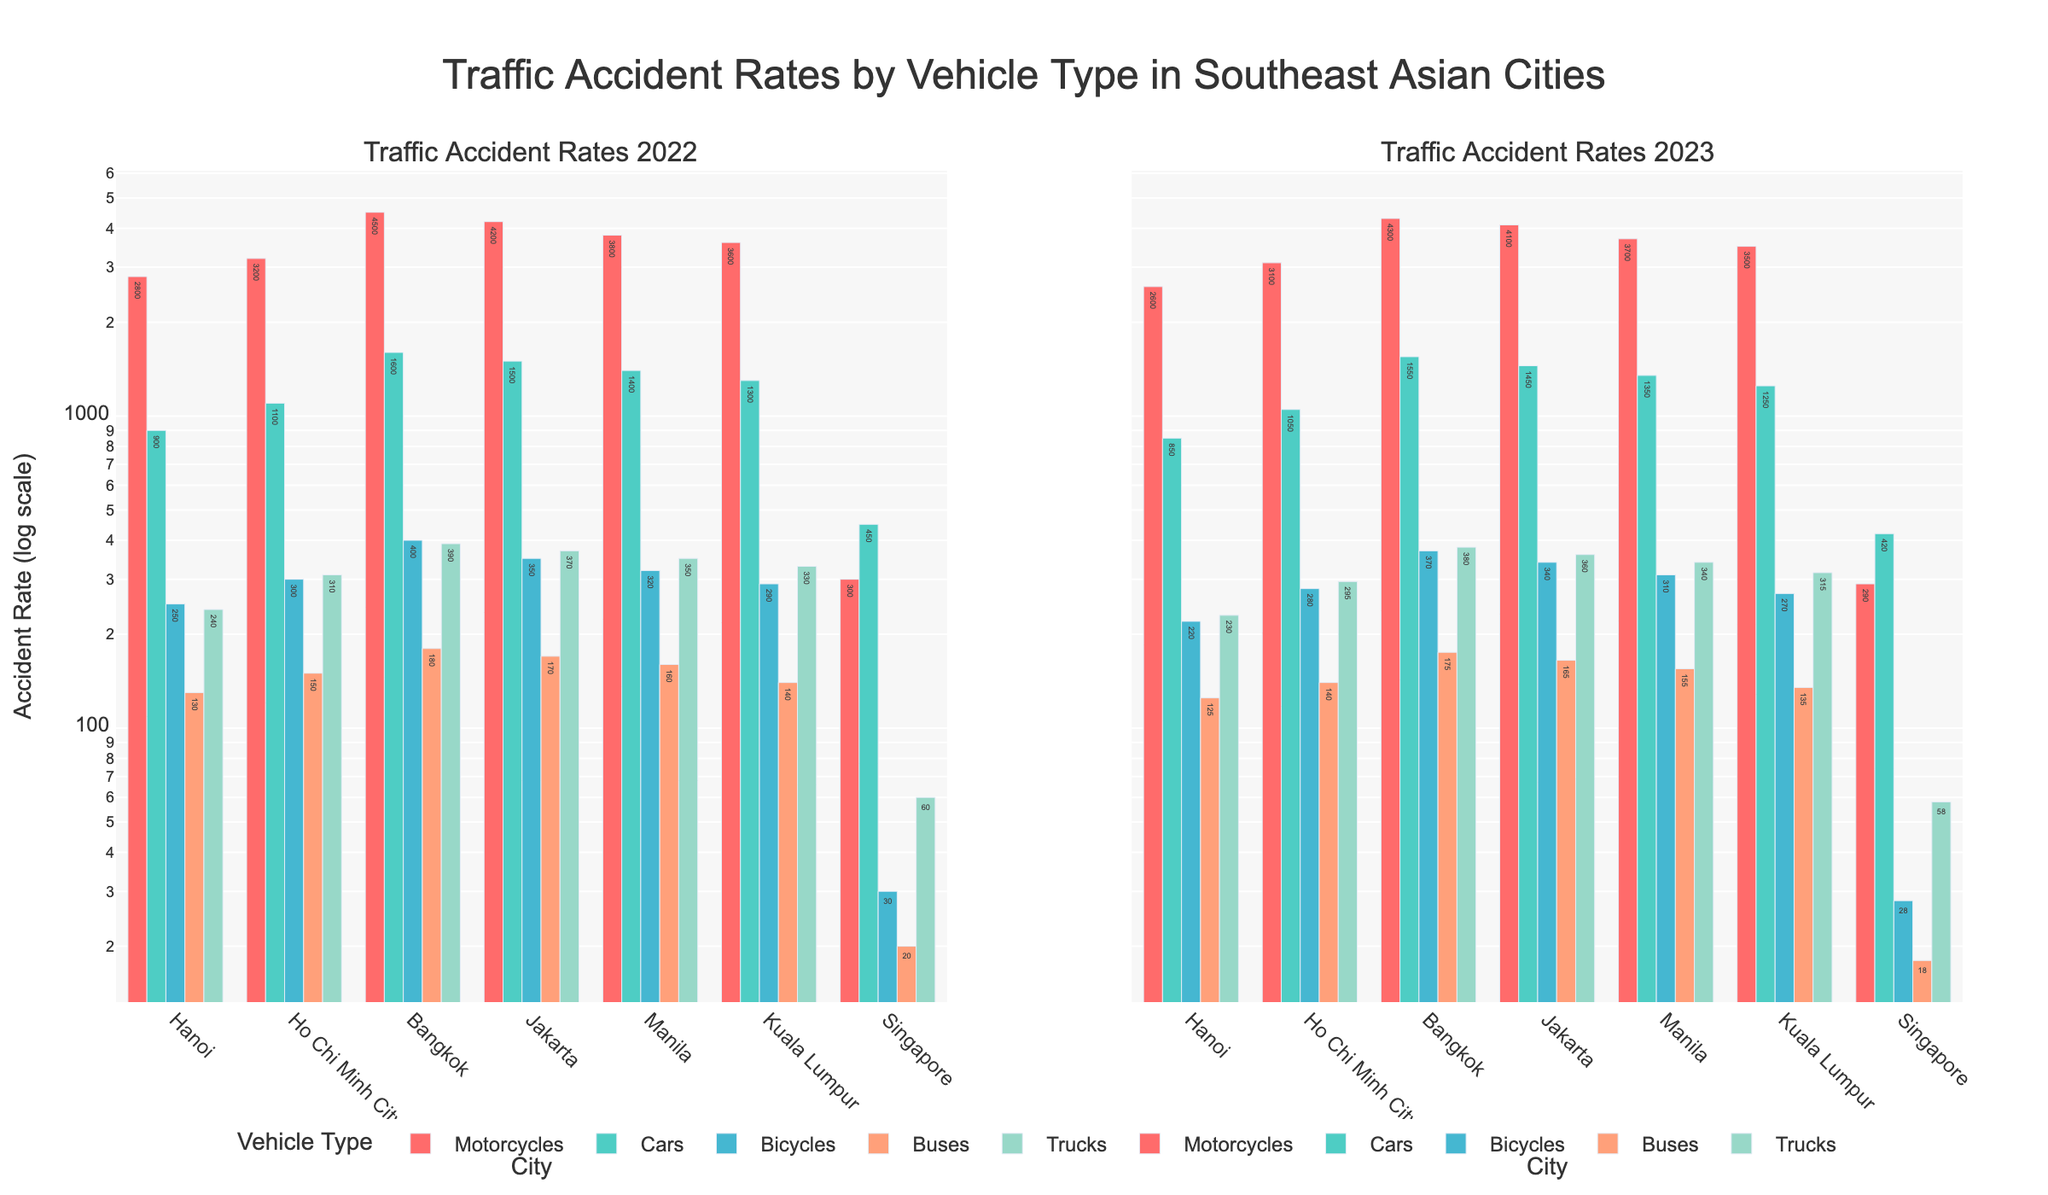What is the title of the figure? The title is located at the top center of the figure. It reads, "Traffic Accident Rates by Vehicle Type in Southeast Asian Cities."
Answer: Traffic Accident Rates by Vehicle Type in Southeast Asian Cities Which city has the highest number of motorcycle accidents in 2022? Look at the first subplot for 2022 and compare the height of the bars for motorcycles across the cities. Bangkok has the tallest bar for motorcycles, indicating the highest number of accidents.
Answer: Bangkok How did the number of traffic accidents involving trucks change in Ho Chi Minh City from 2022 to 2023? Observe the truck accident bars for Ho Chi Minh City in both subplots. The height decreased from 310 (in 2022) to 295 (in 2023).
Answer: Decreased Which city has the lowest number of bicycle accidents in both 2022 and 2023? Compare the heights of the bars for bicycles in both years across all cities. Singapore has the shortest bars for bicycles in both subplots.
Answer: Singapore Are there more bus accidents in Hanoi or Jakarta in 2023? In the 2023 subplot, compare the heights of the bars for buses between Hanoi and Jakarta. Jakarta's bar is slightly higher than Hanoi's.
Answer: Jakarta What is the dominant vehicle type in terms of traffic accidents in Manila in 2022? Look at the Manila bars in the 2022 subplot and identify which vehicle type has the highest bar. The motorcycle bar is the tallest.
Answer: Motorcycles By how much did the number of car accidents in Kuala Lumpur change from 2022 to 2023? Compare the car accident bars for Kuala Lumpur in both subplots. The change is from 1300 in 2022 to 1250 in 2023, a decrease of 50.
Answer: Decreased by 50 Which type of vehicle saw the most significant reduction in traffic accidents in Bangkok from 2022 to 2023? Compare the bars for each vehicle type in Bangkok for both years. Most bars show a slight reduction, but cars saw the most significant reduction from 1600 to 1550, a reduction of 50.
Answer: Cars In which city did the number of bus accidents remain the same from 2022 to 2023? Compare the bus accident bars for all cities between the two years. Hanoi's bus accident rate remains the same at 130.
Answer: Hanoi Which city shows a significant dip in truck-related accidents from 2022 to 2023 as compared to other cities? Observe the truck accident bars across cities in both years and notice the height change. Bangkok shows the most significant decrease from 390 to 380, albeit slight, other changes are even less.
Answer: Bangkok 